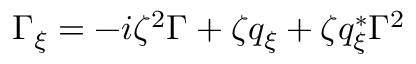<formula> <loc_0><loc_0><loc_500><loc_500>\begin{array} { r } { \Gamma _ { \xi } = - i \zeta ^ { 2 } \Gamma + \zeta q _ { \xi } + \zeta q _ { \xi } ^ { * } \Gamma ^ { 2 } } \end{array}</formula> 